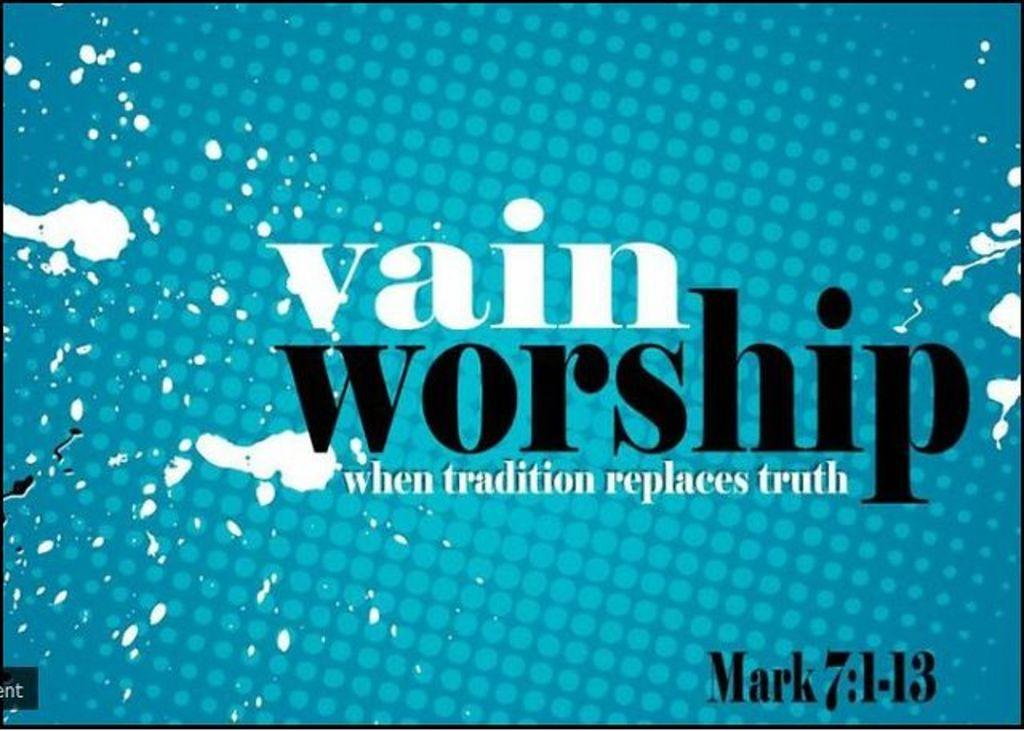<image>
Summarize the visual content of the image. An ad for worship is labeled as Mark 7:1-13. 